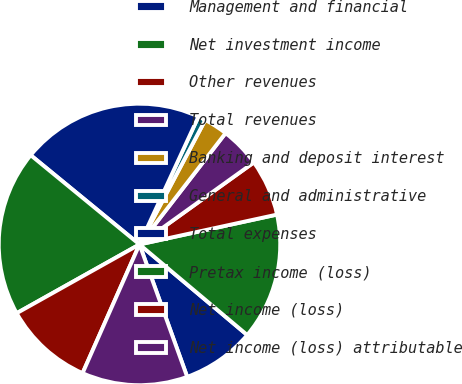Convert chart. <chart><loc_0><loc_0><loc_500><loc_500><pie_chart><fcel>Management and financial<fcel>Net investment income<fcel>Other revenues<fcel>Total revenues<fcel>Banking and deposit interest<fcel>General and administrative<fcel>Total expenses<fcel>Pretax income (loss)<fcel>Net income (loss)<fcel>Net income (loss) attributable<nl><fcel>8.37%<fcel>14.53%<fcel>6.5%<fcel>4.62%<fcel>2.74%<fcel>0.86%<fcel>20.94%<fcel>19.06%<fcel>10.25%<fcel>12.13%<nl></chart> 